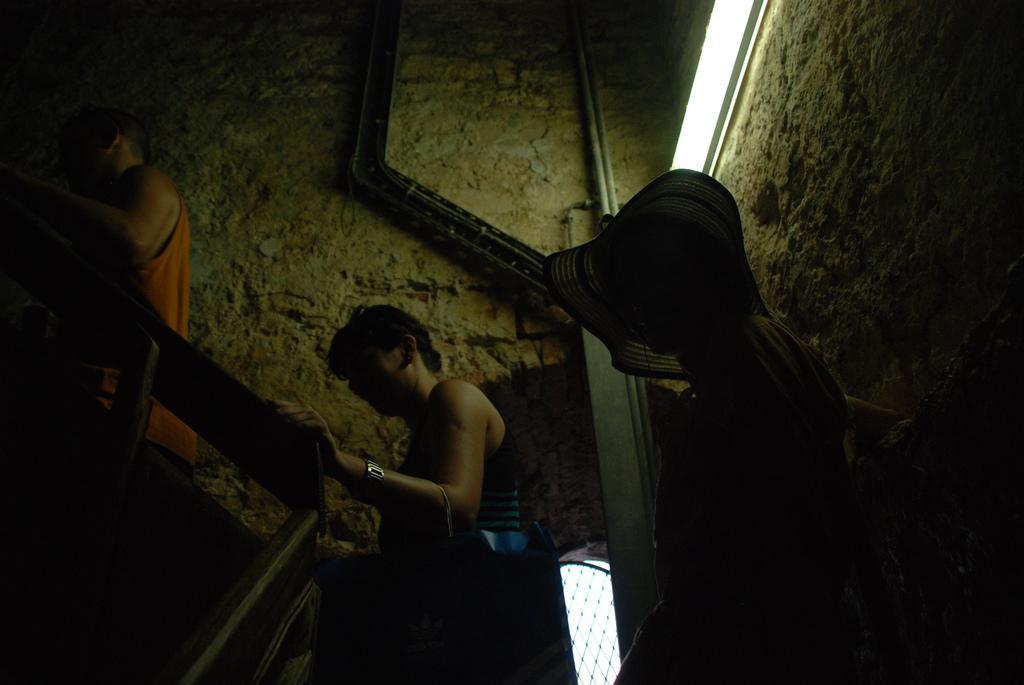Describe this image in one or two sentences. In the center of the image there are people climbing stairs. There is a staircase railing. In the background of the image there is a wall. There are pipes. 